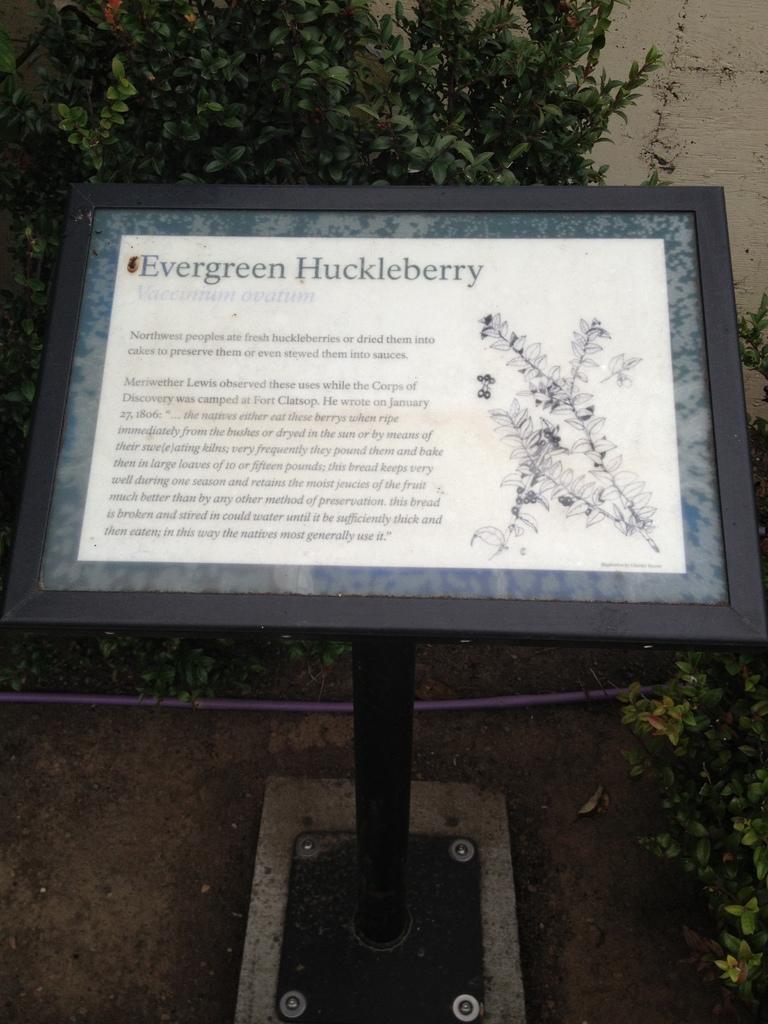Please provide a concise description of this image. In this image in the front there is a board with some text written on it. In the background there are plants and there is a wall. 